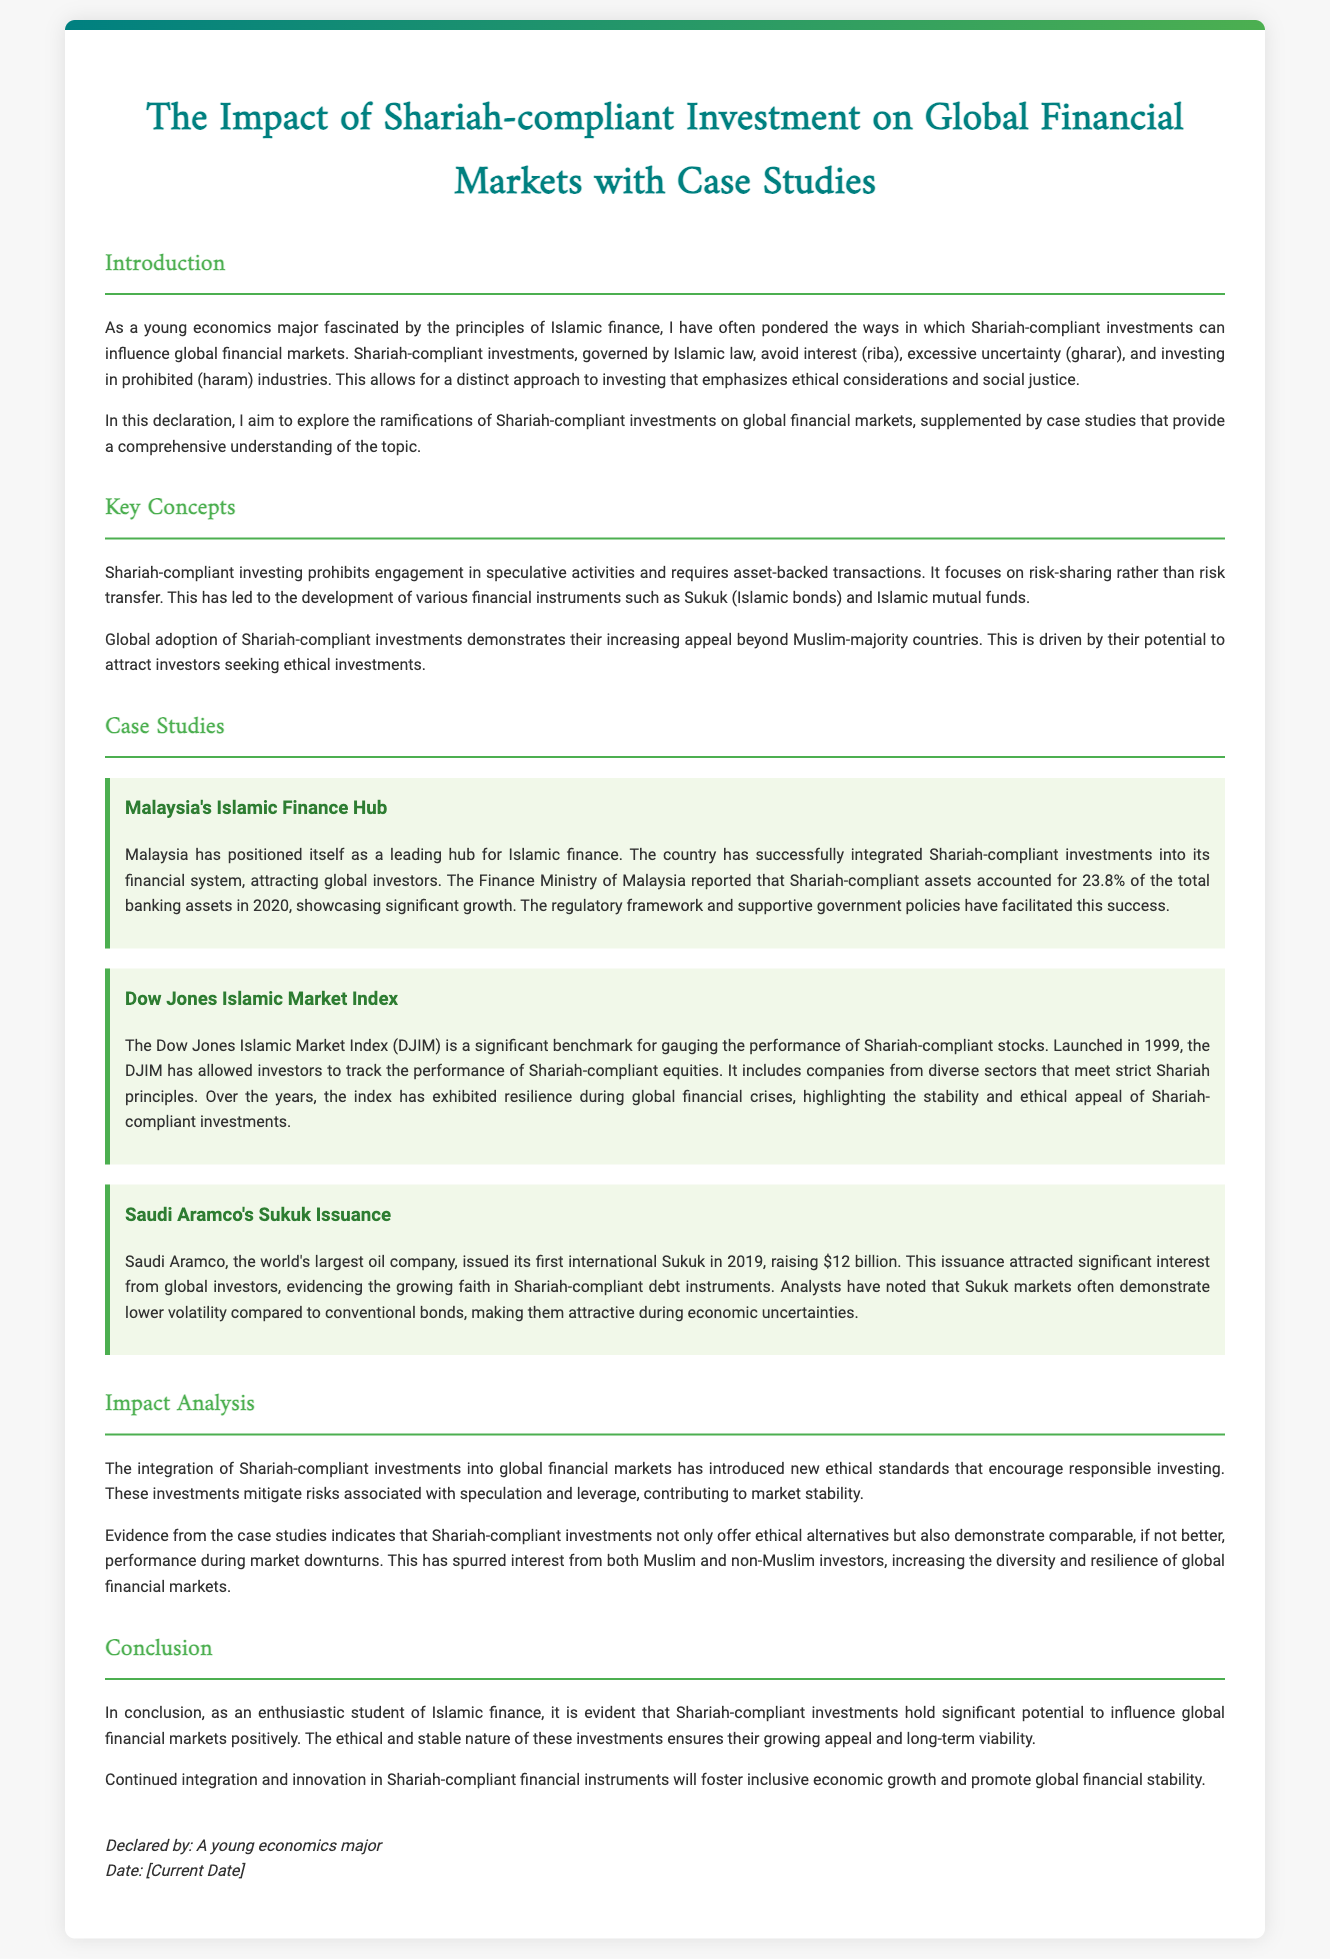What is the title of the document? The title is stated at the beginning of the document, summarizing the main subject.
Answer: The Impact of Shariah-compliant Investment on Global Financial Markets with Case Studies What percentage of total banking assets in Malaysia were Shariah-compliant in 2020? The document mentions the percentage of Shariah-compliant assets in Malaysia's financial system in a specific year.
Answer: 23.8% What is the name of the index launched in 1999 for Shariah-compliant stocks? The document provides the name of the significant benchmark for Shariah-compliant equities.
Answer: Dow Jones Islamic Market Index How much did Saudi Aramco raise through its first international Sukuk issuance? The document specifies the amount raised by Saudi Aramco in its Sukuk issuance.
Answer: $12 billion What are the key prohibitions in Shariah-compliant investing? The document outlines the main prohibitions that govern Shariah-compliant investments.
Answer: Interest (riba), excessive uncertainty (gharar), and investing in prohibited (haram) industries What is a primary benefit of Shariah-compliant investments mentioned in the impact analysis? The document discusses the introduction of new ethical standards as a primary benefit of Shariah-compliant investments.
Answer: Responsible investing What does the document suggest about Shariah-compliant investments during market downturns? The document provides information on the performance of Shariah-compliant investments during economic downturns.
Answer: Comparable, if not better, performance Who declared the document? The document includes the declaration made by the author, specifying their identity as a student.
Answer: A young economics major 